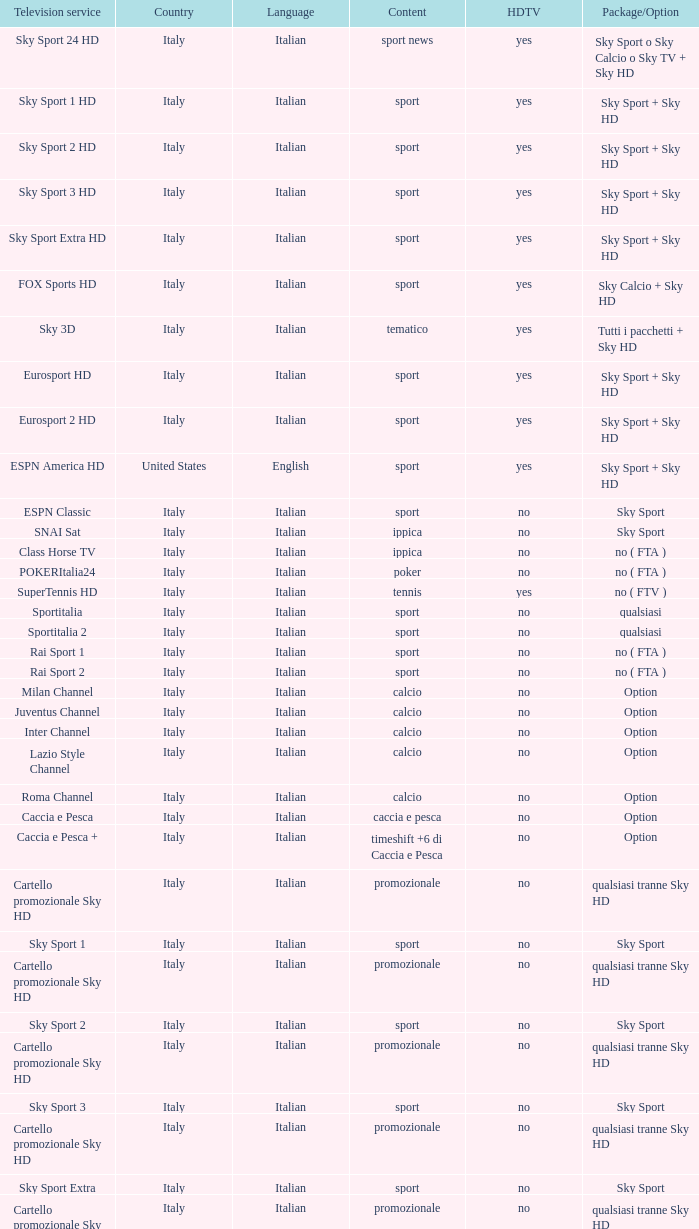Would you mind parsing the complete table? {'header': ['Television service', 'Country', 'Language', 'Content', 'HDTV', 'Package/Option'], 'rows': [['Sky Sport 24 HD', 'Italy', 'Italian', 'sport news', 'yes', 'Sky Sport o Sky Calcio o Sky TV + Sky HD'], ['Sky Sport 1 HD', 'Italy', 'Italian', 'sport', 'yes', 'Sky Sport + Sky HD'], ['Sky Sport 2 HD', 'Italy', 'Italian', 'sport', 'yes', 'Sky Sport + Sky HD'], ['Sky Sport 3 HD', 'Italy', 'Italian', 'sport', 'yes', 'Sky Sport + Sky HD'], ['Sky Sport Extra HD', 'Italy', 'Italian', 'sport', 'yes', 'Sky Sport + Sky HD'], ['FOX Sports HD', 'Italy', 'Italian', 'sport', 'yes', 'Sky Calcio + Sky HD'], ['Sky 3D', 'Italy', 'Italian', 'tematico', 'yes', 'Tutti i pacchetti + Sky HD'], ['Eurosport HD', 'Italy', 'Italian', 'sport', 'yes', 'Sky Sport + Sky HD'], ['Eurosport 2 HD', 'Italy', 'Italian', 'sport', 'yes', 'Sky Sport + Sky HD'], ['ESPN America HD', 'United States', 'English', 'sport', 'yes', 'Sky Sport + Sky HD'], ['ESPN Classic', 'Italy', 'Italian', 'sport', 'no', 'Sky Sport'], ['SNAI Sat', 'Italy', 'Italian', 'ippica', 'no', 'Sky Sport'], ['Class Horse TV', 'Italy', 'Italian', 'ippica', 'no', 'no ( FTA )'], ['POKERItalia24', 'Italy', 'Italian', 'poker', 'no', 'no ( FTA )'], ['SuperTennis HD', 'Italy', 'Italian', 'tennis', 'yes', 'no ( FTV )'], ['Sportitalia', 'Italy', 'Italian', 'sport', 'no', 'qualsiasi'], ['Sportitalia 2', 'Italy', 'Italian', 'sport', 'no', 'qualsiasi'], ['Rai Sport 1', 'Italy', 'Italian', 'sport', 'no', 'no ( FTA )'], ['Rai Sport 2', 'Italy', 'Italian', 'sport', 'no', 'no ( FTA )'], ['Milan Channel', 'Italy', 'Italian', 'calcio', 'no', 'Option'], ['Juventus Channel', 'Italy', 'Italian', 'calcio', 'no', 'Option'], ['Inter Channel', 'Italy', 'Italian', 'calcio', 'no', 'Option'], ['Lazio Style Channel', 'Italy', 'Italian', 'calcio', 'no', 'Option'], ['Roma Channel', 'Italy', 'Italian', 'calcio', 'no', 'Option'], ['Caccia e Pesca', 'Italy', 'Italian', 'caccia e pesca', 'no', 'Option'], ['Caccia e Pesca +', 'Italy', 'Italian', 'timeshift +6 di Caccia e Pesca', 'no', 'Option'], ['Cartello promozionale Sky HD', 'Italy', 'Italian', 'promozionale', 'no', 'qualsiasi tranne Sky HD'], ['Sky Sport 1', 'Italy', 'Italian', 'sport', 'no', 'Sky Sport'], ['Cartello promozionale Sky HD', 'Italy', 'Italian', 'promozionale', 'no', 'qualsiasi tranne Sky HD'], ['Sky Sport 2', 'Italy', 'Italian', 'sport', 'no', 'Sky Sport'], ['Cartello promozionale Sky HD', 'Italy', 'Italian', 'promozionale', 'no', 'qualsiasi tranne Sky HD'], ['Sky Sport 3', 'Italy', 'Italian', 'sport', 'no', 'Sky Sport'], ['Cartello promozionale Sky HD', 'Italy', 'Italian', 'promozionale', 'no', 'qualsiasi tranne Sky HD'], ['Sky Sport Extra', 'Italy', 'Italian', 'sport', 'no', 'Sky Sport'], ['Cartello promozionale Sky HD', 'Italy', 'Italian', 'promozionale', 'no', 'qualsiasi tranne Sky HD'], ['Sky Supercalcio', 'Italy', 'Italian', 'calcio', 'no', 'Sky Calcio'], ['Cartello promozionale Sky HD', 'Italy', 'Italian', 'promozionale', 'no', 'qualsiasi tranne Sky HD'], ['Eurosport', 'Italy', 'Italian', 'sport', 'no', 'Sky Sport'], ['Eurosport 2', 'Italy', 'Italian', 'sport', 'no', 'Sky Sport'], ['ESPN America', 'Italy', 'Italian', 'sport', 'no', 'Sky Sport']]} What is Country, when Television Service is Eurosport 2? Italy. 